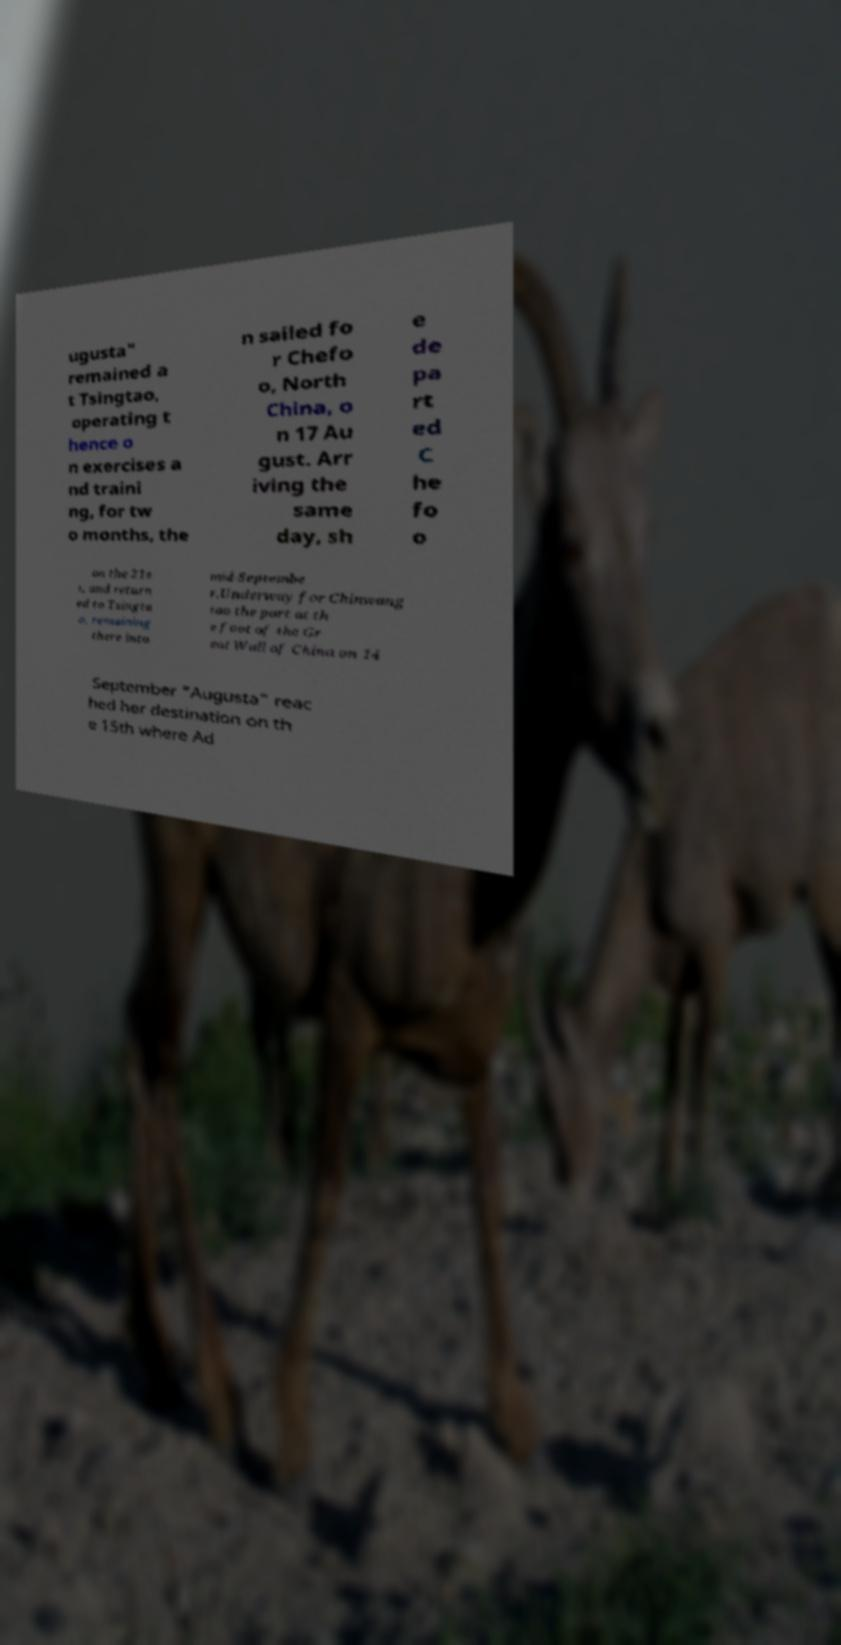Please read and relay the text visible in this image. What does it say? ugusta" remained a t Tsingtao, operating t hence o n exercises a nd traini ng, for tw o months, the n sailed fo r Chefo o, North China, o n 17 Au gust. Arr iving the same day, sh e de pa rt ed C he fo o on the 21s t, and return ed to Tsingta o, remaining there into mid-Septembe r.Underway for Chinwang tao the port at th e foot of the Gr eat Wall of China on 14 September "Augusta" reac hed her destination on th e 15th where Ad 